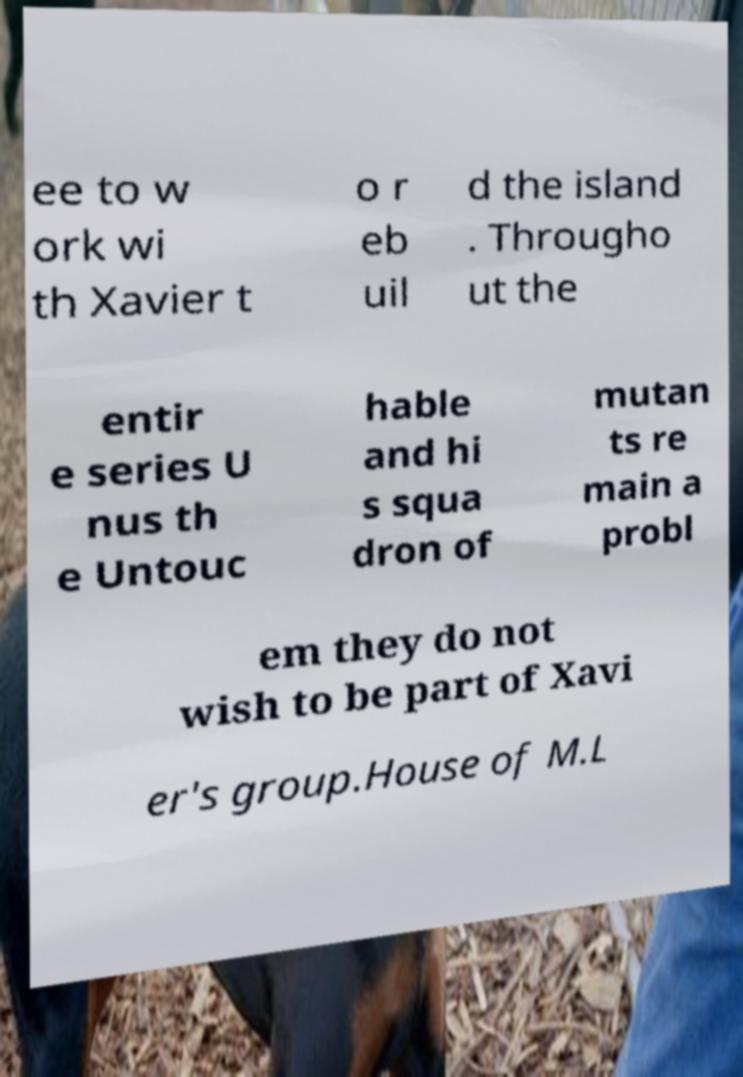Please identify and transcribe the text found in this image. ee to w ork wi th Xavier t o r eb uil d the island . Througho ut the entir e series U nus th e Untouc hable and hi s squa dron of mutan ts re main a probl em they do not wish to be part of Xavi er's group.House of M.L 